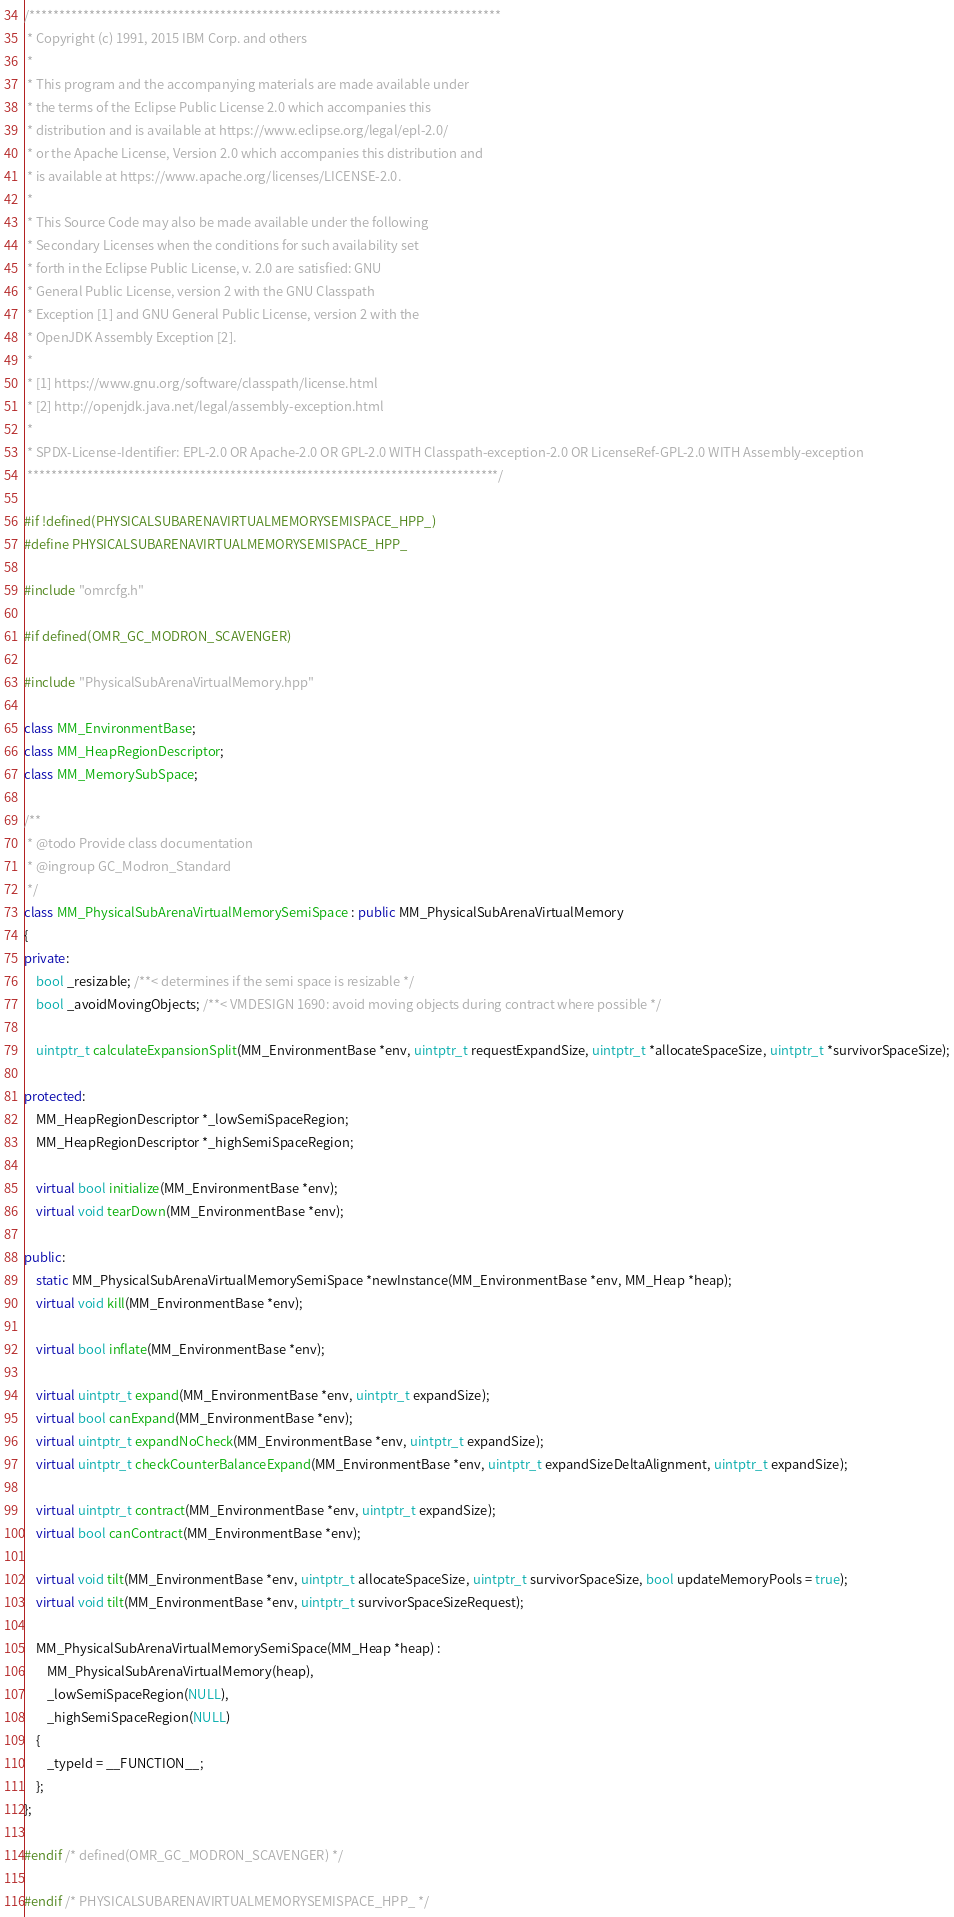<code> <loc_0><loc_0><loc_500><loc_500><_C++_>/*******************************************************************************
 * Copyright (c) 1991, 2015 IBM Corp. and others
 *
 * This program and the accompanying materials are made available under
 * the terms of the Eclipse Public License 2.0 which accompanies this
 * distribution and is available at https://www.eclipse.org/legal/epl-2.0/
 * or the Apache License, Version 2.0 which accompanies this distribution and
 * is available at https://www.apache.org/licenses/LICENSE-2.0.
 *
 * This Source Code may also be made available under the following
 * Secondary Licenses when the conditions for such availability set
 * forth in the Eclipse Public License, v. 2.0 are satisfied: GNU
 * General Public License, version 2 with the GNU Classpath
 * Exception [1] and GNU General Public License, version 2 with the
 * OpenJDK Assembly Exception [2].
 *
 * [1] https://www.gnu.org/software/classpath/license.html
 * [2] http://openjdk.java.net/legal/assembly-exception.html
 *
 * SPDX-License-Identifier: EPL-2.0 OR Apache-2.0 OR GPL-2.0 WITH Classpath-exception-2.0 OR LicenseRef-GPL-2.0 WITH Assembly-exception
 *******************************************************************************/

#if !defined(PHYSICALSUBARENAVIRTUALMEMORYSEMISPACE_HPP_)
#define PHYSICALSUBARENAVIRTUALMEMORYSEMISPACE_HPP_

#include "omrcfg.h"

#if defined(OMR_GC_MODRON_SCAVENGER)

#include "PhysicalSubArenaVirtualMemory.hpp"

class MM_EnvironmentBase;
class MM_HeapRegionDescriptor;
class MM_MemorySubSpace;

/**
 * @todo Provide class documentation
 * @ingroup GC_Modron_Standard
 */
class MM_PhysicalSubArenaVirtualMemorySemiSpace : public MM_PhysicalSubArenaVirtualMemory
{
private:
	bool _resizable; /**< determines if the semi space is resizable */
	bool _avoidMovingObjects; /**< VMDESIGN 1690: avoid moving objects during contract where possible */

	uintptr_t calculateExpansionSplit(MM_EnvironmentBase *env, uintptr_t requestExpandSize, uintptr_t *allocateSpaceSize, uintptr_t *survivorSpaceSize);

protected:
	MM_HeapRegionDescriptor *_lowSemiSpaceRegion;
	MM_HeapRegionDescriptor *_highSemiSpaceRegion;

	virtual bool initialize(MM_EnvironmentBase *env);
	virtual void tearDown(MM_EnvironmentBase *env);

public:
	static MM_PhysicalSubArenaVirtualMemorySemiSpace *newInstance(MM_EnvironmentBase *env, MM_Heap *heap);
	virtual void kill(MM_EnvironmentBase *env);

	virtual bool inflate(MM_EnvironmentBase *env);

	virtual uintptr_t expand(MM_EnvironmentBase *env, uintptr_t expandSize);
	virtual bool canExpand(MM_EnvironmentBase *env);
	virtual uintptr_t expandNoCheck(MM_EnvironmentBase *env, uintptr_t expandSize);
	virtual uintptr_t checkCounterBalanceExpand(MM_EnvironmentBase *env, uintptr_t expandSizeDeltaAlignment, uintptr_t expandSize);

	virtual uintptr_t contract(MM_EnvironmentBase *env, uintptr_t expandSize);
	virtual bool canContract(MM_EnvironmentBase *env);

	virtual void tilt(MM_EnvironmentBase *env, uintptr_t allocateSpaceSize, uintptr_t survivorSpaceSize, bool updateMemoryPools = true);
	virtual void tilt(MM_EnvironmentBase *env, uintptr_t survivorSpaceSizeRequest);

	MM_PhysicalSubArenaVirtualMemorySemiSpace(MM_Heap *heap) :
		MM_PhysicalSubArenaVirtualMemory(heap),
		_lowSemiSpaceRegion(NULL),
		_highSemiSpaceRegion(NULL)
	{
		_typeId = __FUNCTION__;
	};
};

#endif /* defined(OMR_GC_MODRON_SCAVENGER) */

#endif /* PHYSICALSUBARENAVIRTUALMEMORYSEMISPACE_HPP_ */
</code> 